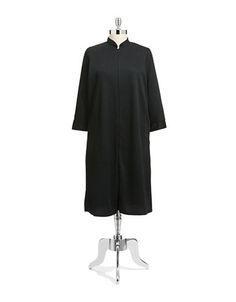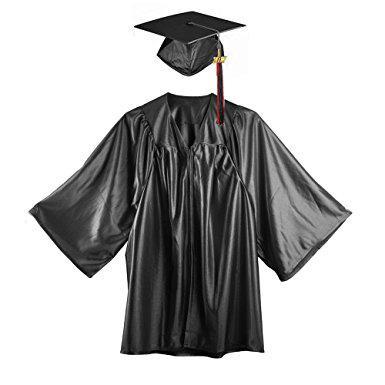The first image is the image on the left, the second image is the image on the right. Analyze the images presented: Is the assertion "An image shows a black graduation robe with bright blue around the collar, and the other image shows an unworn solid-colored gown." valid? Answer yes or no. No. 